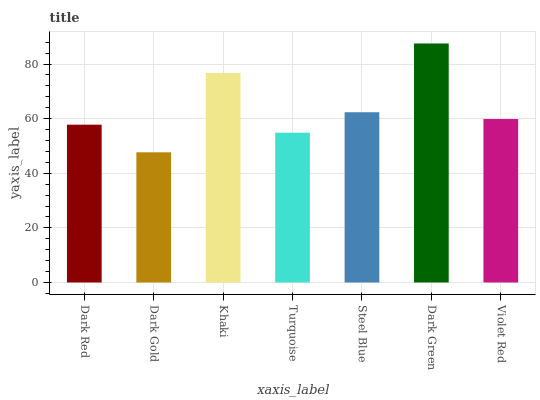Is Dark Gold the minimum?
Answer yes or no. Yes. Is Dark Green the maximum?
Answer yes or no. Yes. Is Khaki the minimum?
Answer yes or no. No. Is Khaki the maximum?
Answer yes or no. No. Is Khaki greater than Dark Gold?
Answer yes or no. Yes. Is Dark Gold less than Khaki?
Answer yes or no. Yes. Is Dark Gold greater than Khaki?
Answer yes or no. No. Is Khaki less than Dark Gold?
Answer yes or no. No. Is Violet Red the high median?
Answer yes or no. Yes. Is Violet Red the low median?
Answer yes or no. Yes. Is Dark Gold the high median?
Answer yes or no. No. Is Dark Red the low median?
Answer yes or no. No. 